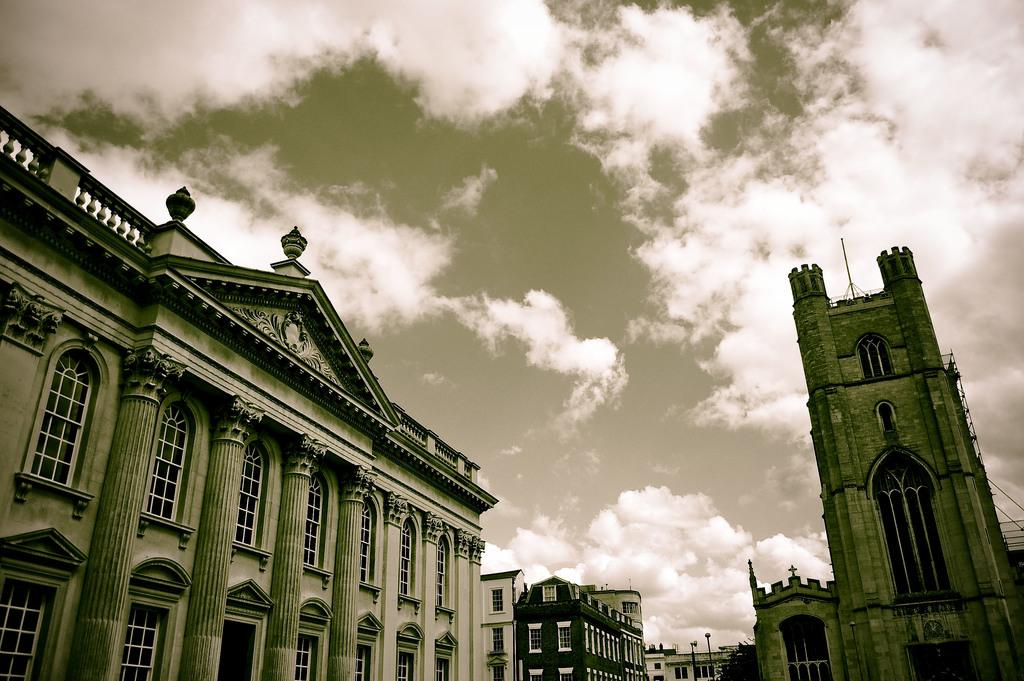What type of structures can be seen in the image? There are buildings in the image. What feature is present on the buildings? There are windows in the image. What can be seen in the background of the image? The sky is visible in the background of the image. What is the condition of the sky in the image? Clouds are present in the sky. What type of hair can be seen on the buildings in the image? There is no hair present on the buildings in the image; they are inanimate structures. 